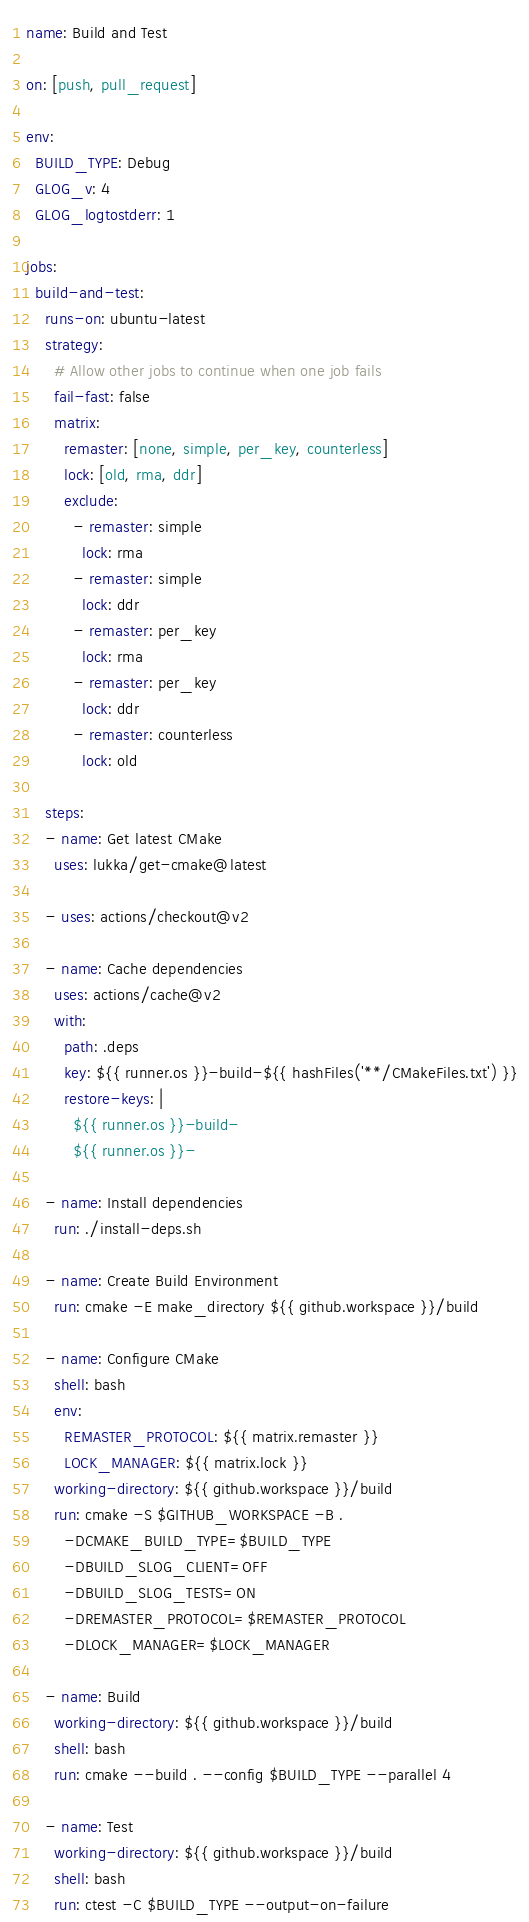<code> <loc_0><loc_0><loc_500><loc_500><_YAML_>name: Build and Test

on: [push, pull_request]

env:
  BUILD_TYPE: Debug
  GLOG_v: 4
  GLOG_logtostderr: 1

jobs:
  build-and-test:
    runs-on: ubuntu-latest
    strategy:
      # Allow other jobs to continue when one job fails
      fail-fast: false
      matrix:
        remaster: [none, simple, per_key, counterless]
        lock: [old, rma, ddr]
        exclude:
          - remaster: simple
            lock: rma
          - remaster: simple
            lock: ddr
          - remaster: per_key
            lock: rma
          - remaster: per_key
            lock: ddr
          - remaster: counterless
            lock: old

    steps:
    - name: Get latest CMake
      uses: lukka/get-cmake@latest

    - uses: actions/checkout@v2

    - name: Cache dependencies
      uses: actions/cache@v2
      with:
        path: .deps
        key: ${{ runner.os }}-build-${{ hashFiles('**/CMakeFiles.txt') }}
        restore-keys: |
          ${{ runner.os }}-build-
          ${{ runner.os }}-

    - name: Install dependencies
      run: ./install-deps.sh

    - name: Create Build Environment
      run: cmake -E make_directory ${{ github.workspace }}/build

    - name: Configure CMake
      shell: bash
      env:
        REMASTER_PROTOCOL: ${{ matrix.remaster }}
        LOCK_MANAGER: ${{ matrix.lock }}
      working-directory: ${{ github.workspace }}/build
      run: cmake -S $GITHUB_WORKSPACE -B . 
        -DCMAKE_BUILD_TYPE=$BUILD_TYPE 
        -DBUILD_SLOG_CLIENT=OFF 
        -DBUILD_SLOG_TESTS=ON
        -DREMASTER_PROTOCOL=$REMASTER_PROTOCOL
        -DLOCK_MANAGER=$LOCK_MANAGER

    - name: Build
      working-directory: ${{ github.workspace }}/build
      shell: bash
      run: cmake --build . --config $BUILD_TYPE --parallel 4

    - name: Test
      working-directory: ${{ github.workspace }}/build
      shell: bash
      run: ctest -C $BUILD_TYPE --output-on-failure
</code> 